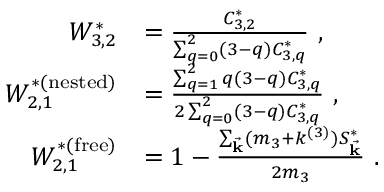Convert formula to latex. <formula><loc_0><loc_0><loc_500><loc_500>\begin{array} { r l } { W _ { 3 , 2 } ^ { * } } & { = \frac { C _ { 3 , 2 } ^ { * } } { \sum _ { q = 0 } ^ { 2 } ( 3 - q ) C _ { 3 , q } ^ { * } } , } \\ { W _ { 2 , 1 } ^ { * ( n e s t e d ) } } & { = \frac { \sum _ { q = 1 } ^ { 2 } q ( 3 - q ) C _ { 3 , q } ^ { * } } { 2 \sum _ { q = 0 } ^ { 2 } ( 3 - q ) C _ { 3 , q } ^ { * } } , } \\ { W _ { 2 , 1 } ^ { * ( f r e e ) } } & { = 1 - \frac { \sum _ { \vec { k } } ( m _ { 3 } + k ^ { ( 3 ) } ) S _ { \vec { k } } ^ { * } } { 2 m _ { 3 } } . } \end{array}</formula> 